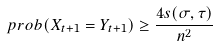Convert formula to latex. <formula><loc_0><loc_0><loc_500><loc_500>\ p r o b ( X _ { t + 1 } = Y _ { t + 1 } ) \geq \frac { 4 s ( \sigma , \tau ) } { n ^ { 2 } }</formula> 